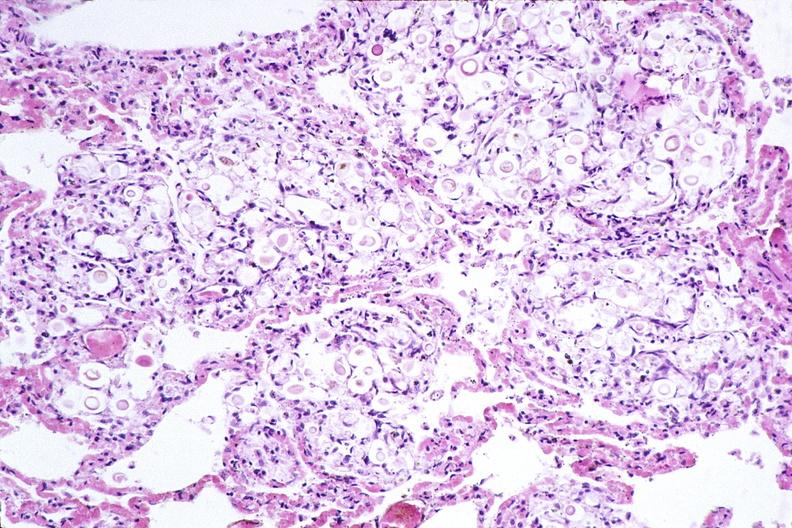what does this image show?
Answer the question using a single word or phrase. Lung 